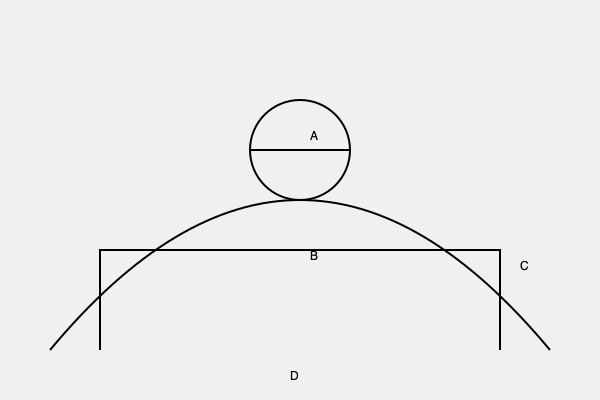In this cross-section of St. Peter's Basilica, which architectural feature is represented by the letter A? To answer this question, let's analyze the labeled cross-section diagram of St. Peter's Basilica:

1. The overall shape of the diagram represents the iconic dome of St. Peter's Basilica.

2. Label A points to a circular structure at the top of the dome.

3. This circular structure is known as the oculus or "eye" of the dome.

4. The oculus serves multiple purposes:
   a) It allows natural light to enter the basilica, illuminating the interior.
   b) It symbolizes the eye of God looking down upon the faithful.
   c) It provides ventilation for the massive interior space.

5. In St. Peter's Basilica, the oculus is actually covered by a lantern, which is a smaller dome-like structure that sits atop the main dome.

6. The lantern not only protects the interior from the elements but also enhances the overall height and grandeur of the basilica.

7. This architectural feature is a hallmark of Renaissance and Baroque church design, perfected by Michelangelo in his work on St. Peter's Basilica.

Therefore, the architectural feature represented by the letter A is the oculus/lantern of the dome.
Answer: Oculus/Lantern 